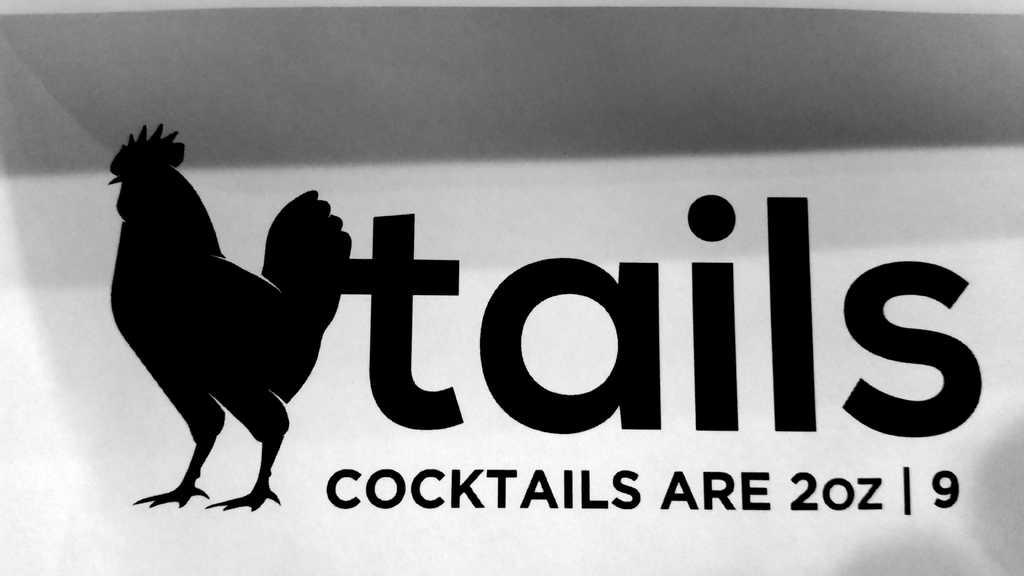What type of animal is in the image? There is a black hen in the image. What color is the text in the image? The text in the image is black. What color is the background of the image? The background of the image is white. What type of cloud can be seen in the image? There are no clouds present in the image; it features a black hen and text on a white background. 